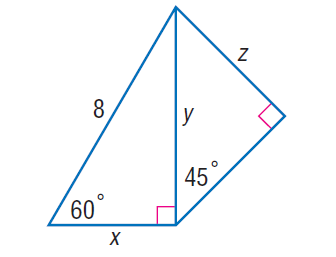Answer the mathemtical geometry problem and directly provide the correct option letter.
Question: Find z.
Choices: A: 2 \sqrt { 6 } B: 6 C: 4 \sqrt { 3 } D: 12 A 